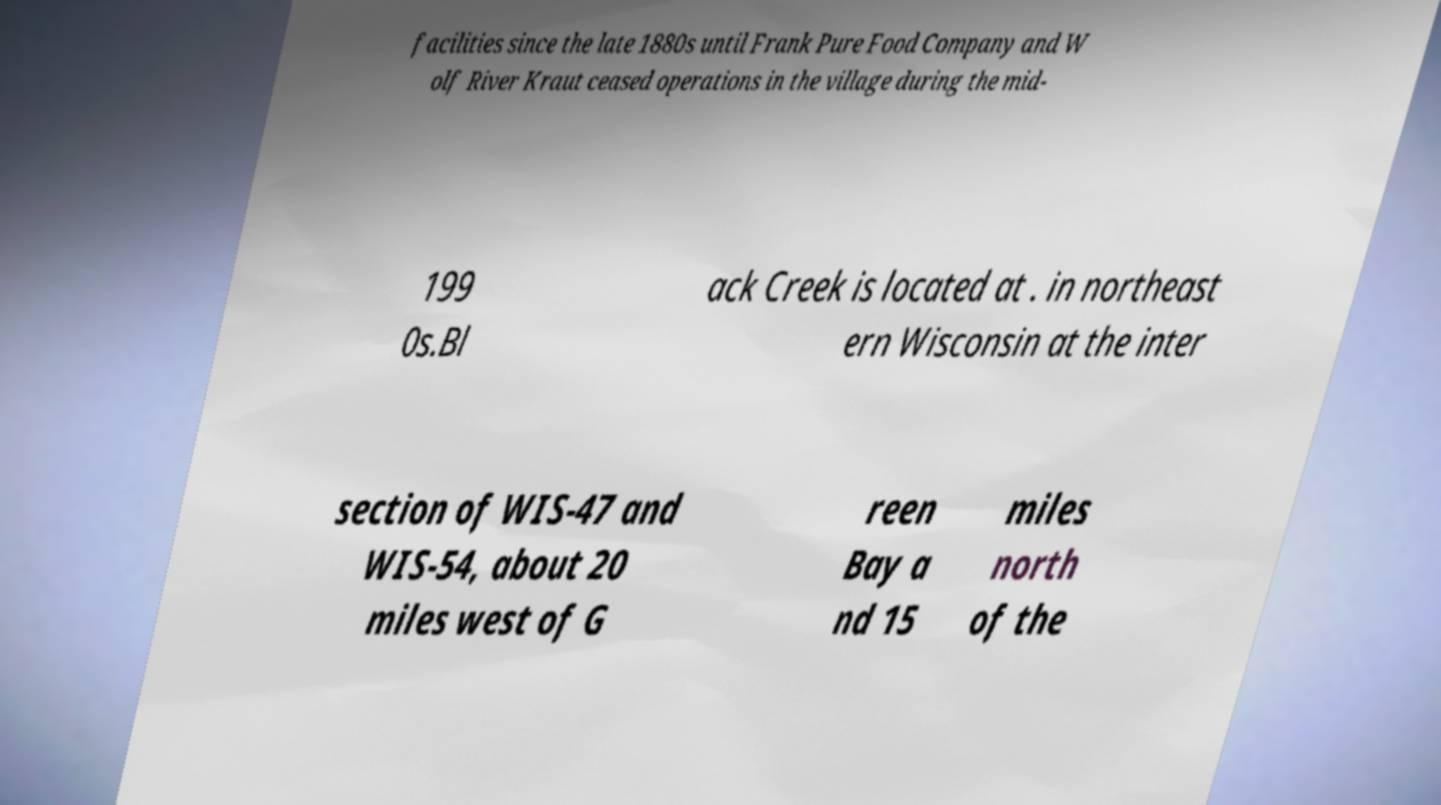Can you read and provide the text displayed in the image?This photo seems to have some interesting text. Can you extract and type it out for me? facilities since the late 1880s until Frank Pure Food Company and W olf River Kraut ceased operations in the village during the mid- 199 0s.Bl ack Creek is located at . in northeast ern Wisconsin at the inter section of WIS-47 and WIS-54, about 20 miles west of G reen Bay a nd 15 miles north of the 